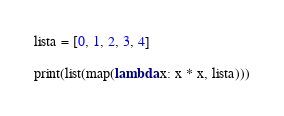Convert code to text. <code><loc_0><loc_0><loc_500><loc_500><_Python_>lista = [0, 1, 2, 3, 4]

print(list(map(lambda x: x * x, lista)))</code> 